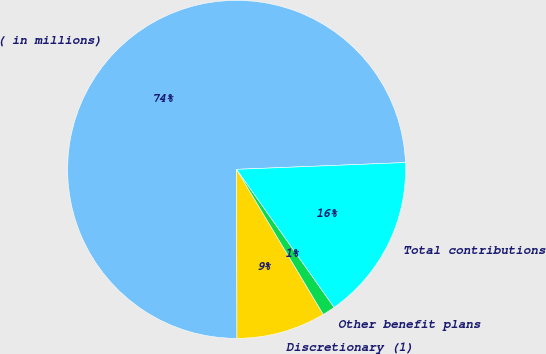<chart> <loc_0><loc_0><loc_500><loc_500><pie_chart><fcel>( in millions)<fcel>Discretionary (1)<fcel>Other benefit plans<fcel>Total contributions<nl><fcel>74.39%<fcel>8.54%<fcel>1.22%<fcel>15.85%<nl></chart> 